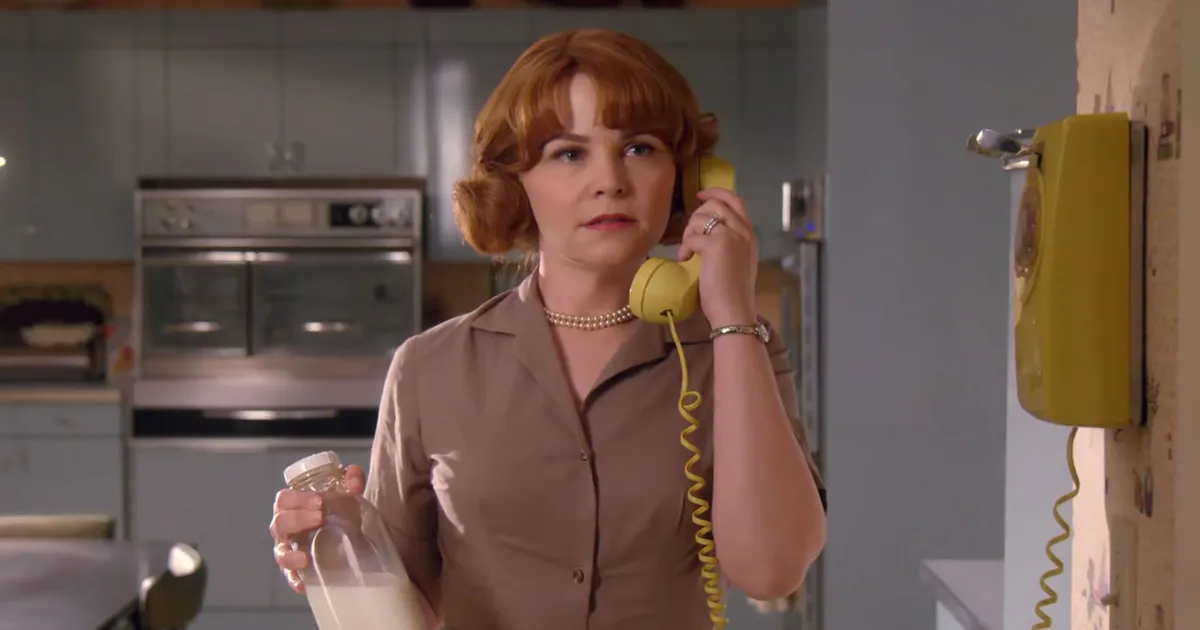What is this photo about? The photo captures a moment featuring actress Ginnifer Goodwin in character as Mary Margaret Blanchard from the TV show 'Once Upon a Time.' She is standing in a quaint, retro-themed kitchen with a blue and white color scheme, which adds to the nostalgic ambiance of the scene. Mary Margaret is in the middle of a phone call, holding a yellow rotary phone to her ear with her left hand, while her right hand grasps a clear glass milk bottle. Her attire consists of a beige dress paired with a classic pearl necklace, and her hair is styled in a neat bob, perfectly complementing the retro setting. The scene epitomizes a slice of everyday life, beautifully captured. 